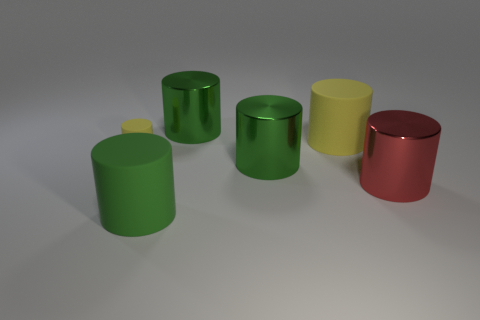Subtract all green cubes. How many yellow cylinders are left? 2 Add 1 small matte things. How many objects exist? 7 Subtract all big yellow cylinders. How many cylinders are left? 5 Subtract 1 cylinders. How many cylinders are left? 5 Subtract all green cylinders. How many cylinders are left? 3 Subtract all gray cylinders. Subtract all purple blocks. How many cylinders are left? 6 Subtract all small objects. Subtract all green rubber objects. How many objects are left? 4 Add 6 yellow things. How many yellow things are left? 8 Add 3 matte objects. How many matte objects exist? 6 Subtract 0 yellow cubes. How many objects are left? 6 